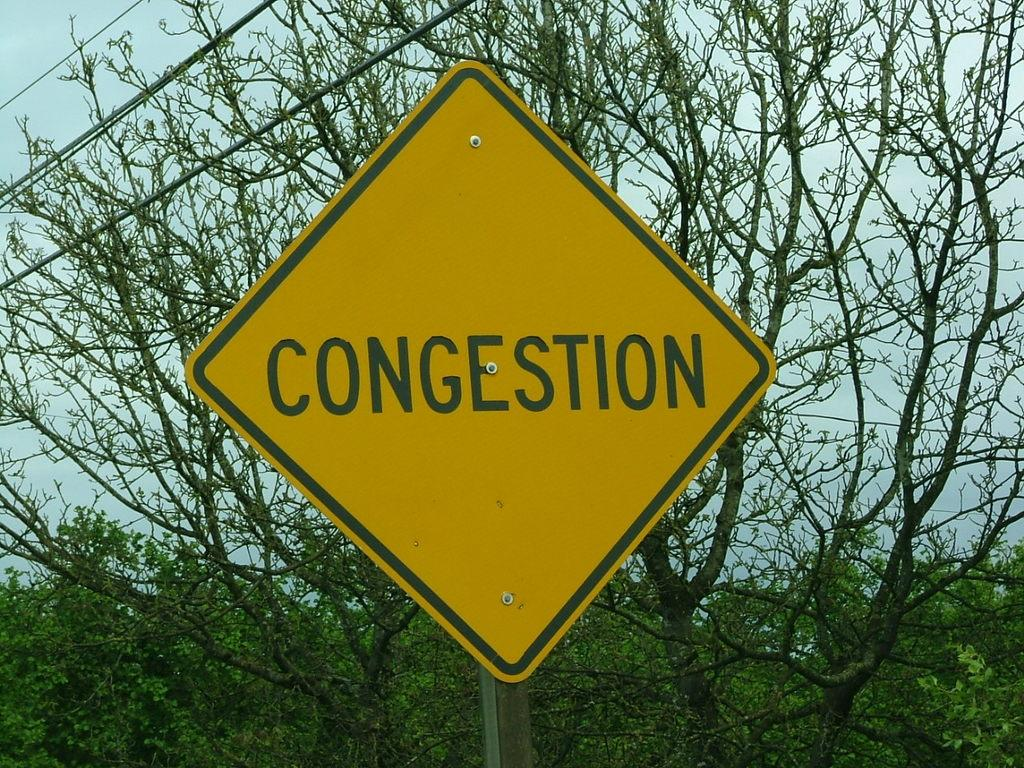What is the main object in the image? There is a yellow color board in the image. What is written or depicted on the board? There is text on the board. What can be seen in the background of the image? There are trees, wires, and the sky visible in the background of the image. What type of orange is being peeled by the actor in the image? There is no orange or actor present in the image; it features a yellow color board with text and a background with trees, wires, and the sky. 